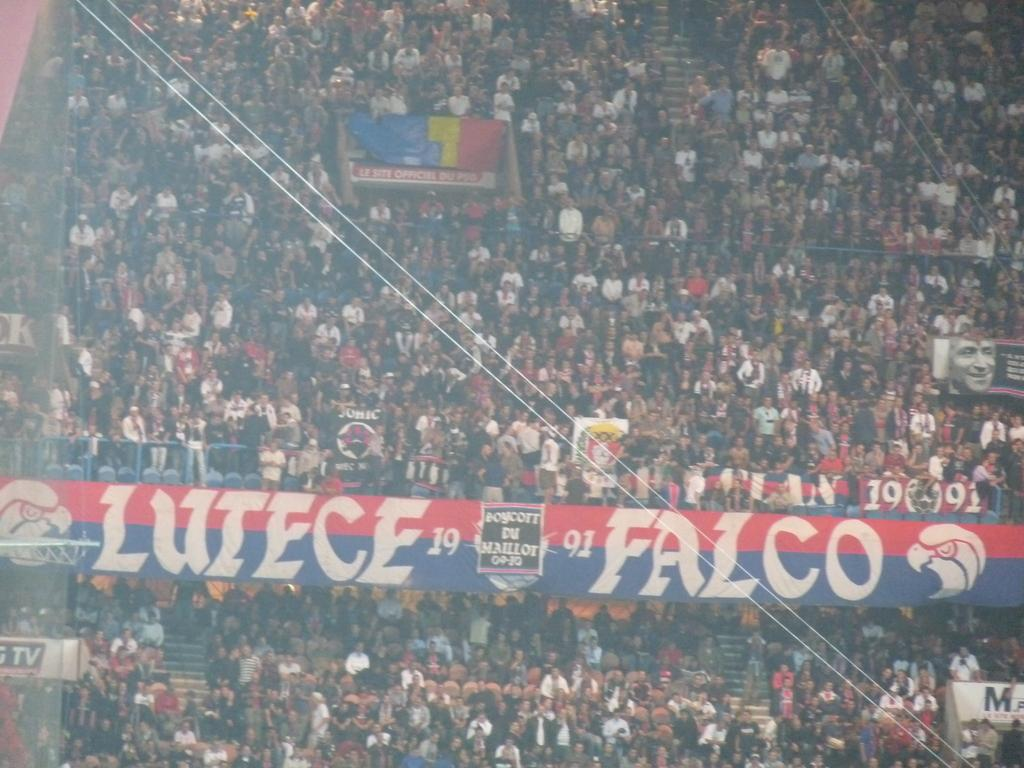How many people are in the image? There is a group of people in the image, but the exact number is not specified. What are the people in the image doing? Some people are sitting, while others are standing. What can be seen hanging in the image? There are banners visible in the image. What else can be seen in the image besides people and banners? There are wires present in the image. What type of skin is visible on the farmer in the image? There is no farmer present in the image, and therefore no skin can be observed. What is the quiver used for in the image? There is no quiver present in the image, so it cannot be used for anything. 